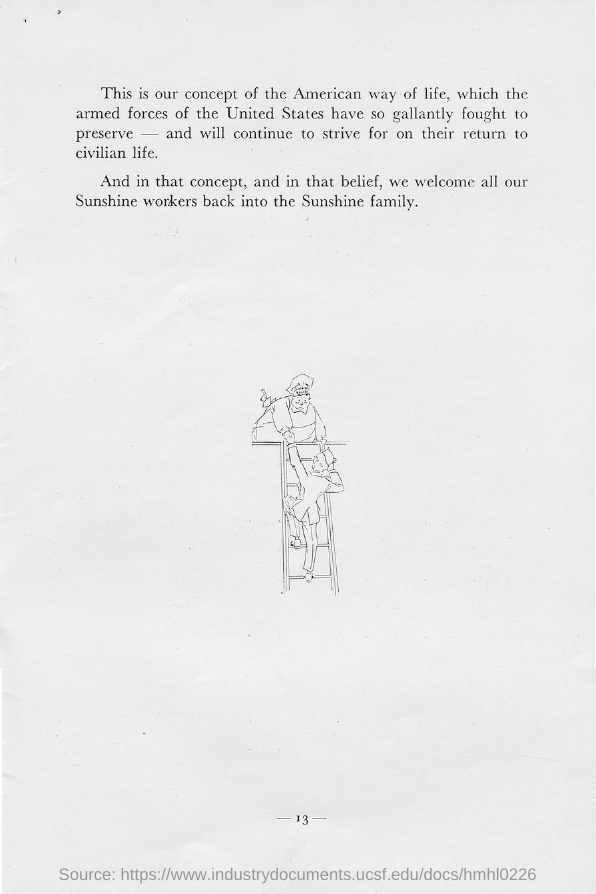What is the page no mentioned in this document?
Your answer should be compact. -13-. 